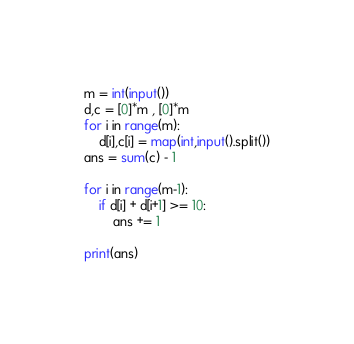Convert code to text. <code><loc_0><loc_0><loc_500><loc_500><_Python_>m = int(input())
d,c = [0]*m , [0]*m
for i in range(m):
    d[i],c[i] = map(int,input().split())
ans = sum(c) - 1
    
for i in range(m-1):
    if d[i] + d[i+1] >= 10:
        ans += 1
        
print(ans)</code> 